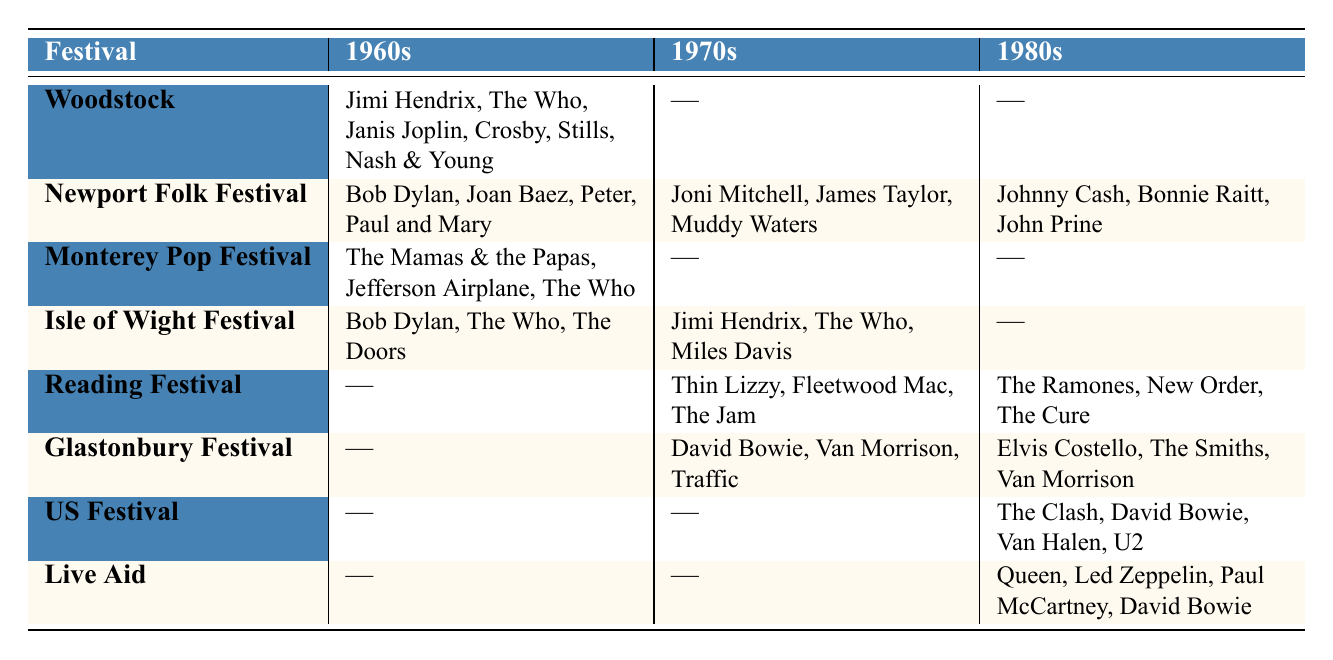What artists performed at Woodstock in the 1960s? The table indicates that the artists who performed at Woodstock in the 1960s are Jimi Hendrix, The Who, Janis Joplin, and Crosby, Stills, Nash & Young.
Answer: Jimi Hendrix, The Who, Janis Joplin, Crosby, Stills, Nash & Young Which festival had performances in the 1980s by Queen and Led Zeppelin? According to the table, only the Live Aid festival in the 1980s featured performances by Queen and Led Zeppelin.
Answer: Live Aid How many festivals had no performances listed in the 1970s? By examining the table, we see that Woodland, Monterey Pop Festival, Reading Festival, Glastonbury Festival, US Festival, and Live Aid have no performances in the 1970s; therefore, three festivals did not feature performances.
Answer: 5 Which decade saw the most varied lineup at the Newport Folk Festival? The discussion involves comparing lineups across decades. In the 1960s, the festival had three artists; in the 1970s, it had three as well; and in the 1980s, it showcased three artists. Since all decades have the same count, they are equally varied.
Answer: All decades are equally varied Are there any artists who performed at more than one festival in the 1960s? Observing the table shows that The Who performed at both Woodstock and Isle of Wight Festival in the 1960s, which confirms that there is at least one artist who performed at more than one festival.
Answer: Yes How does the number of unique artists at the Reading Festival in the 1980s compare to those in the 1970s? For the Reading Festival, there are three unique artists in the 1980s (The Ramones, New Order, The Cure) and three in the 1970s (Thin Lizzy, Fleetwood Mac, The Jam). This indicates that the number of unique artists is the same in both decades.
Answer: They are the same Which festivals consistently featured performances from Jimi Hendrix? By reviewing the data, Jimi Hendrix is noted in both the 1960s at Woodstock and the 1970s at Isle of Wight Festival, showing that he consistently performed but only in two of the three provided decades.
Answer: Woodstock and Isle of Wight Festival 